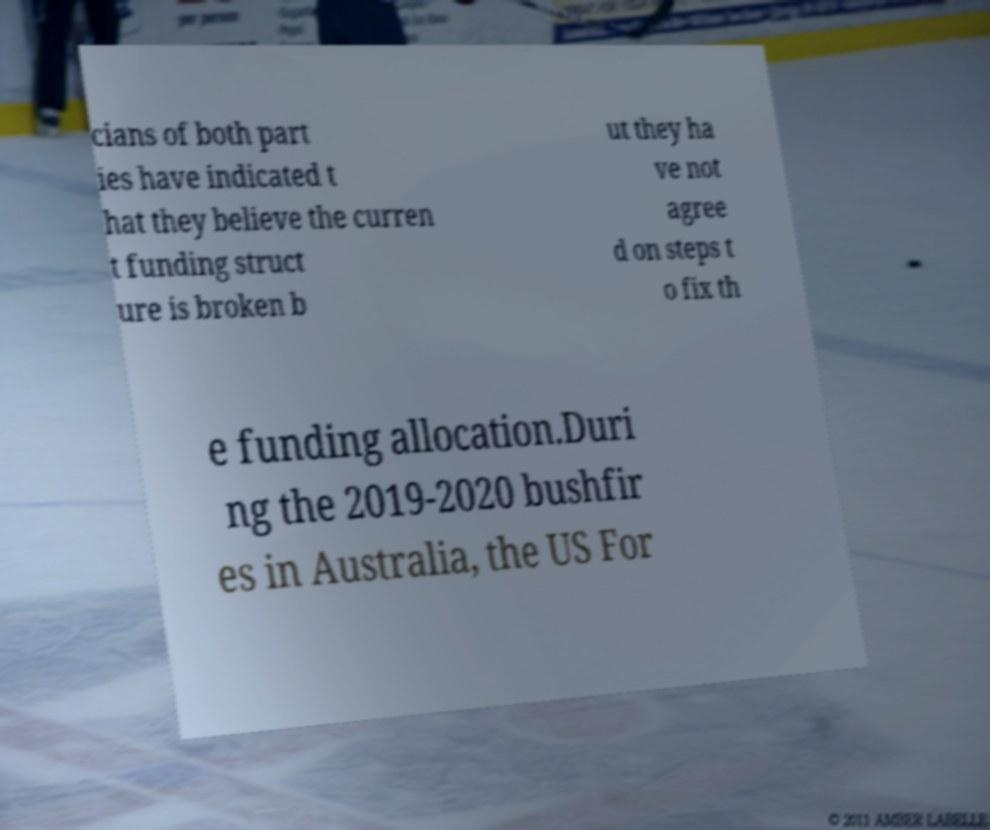What messages or text are displayed in this image? I need them in a readable, typed format. cians of both part ies have indicated t hat they believe the curren t funding struct ure is broken b ut they ha ve not agree d on steps t o fix th e funding allocation.Duri ng the 2019-2020 bushfir es in Australia, the US For 